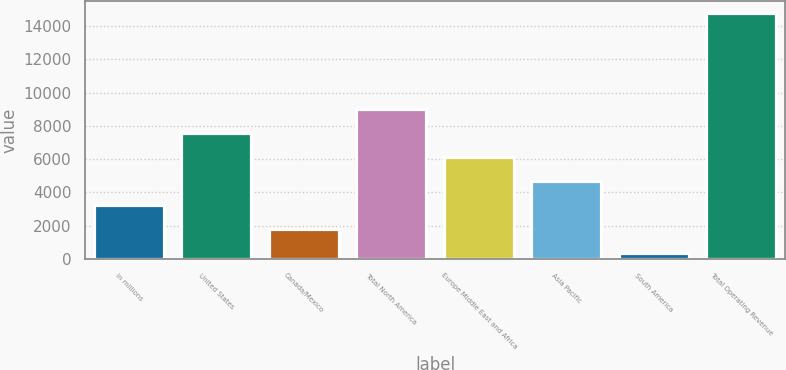Convert chart. <chart><loc_0><loc_0><loc_500><loc_500><bar_chart><fcel>In millions<fcel>United States<fcel>Canada/Mexico<fcel>Total North America<fcel>Europe Middle East and Africa<fcel>Asia Pacific<fcel>South America<fcel>Total Operating Revenue<nl><fcel>3227.2<fcel>7555<fcel>1784.6<fcel>8997.6<fcel>6112.4<fcel>4669.8<fcel>342<fcel>14768<nl></chart> 